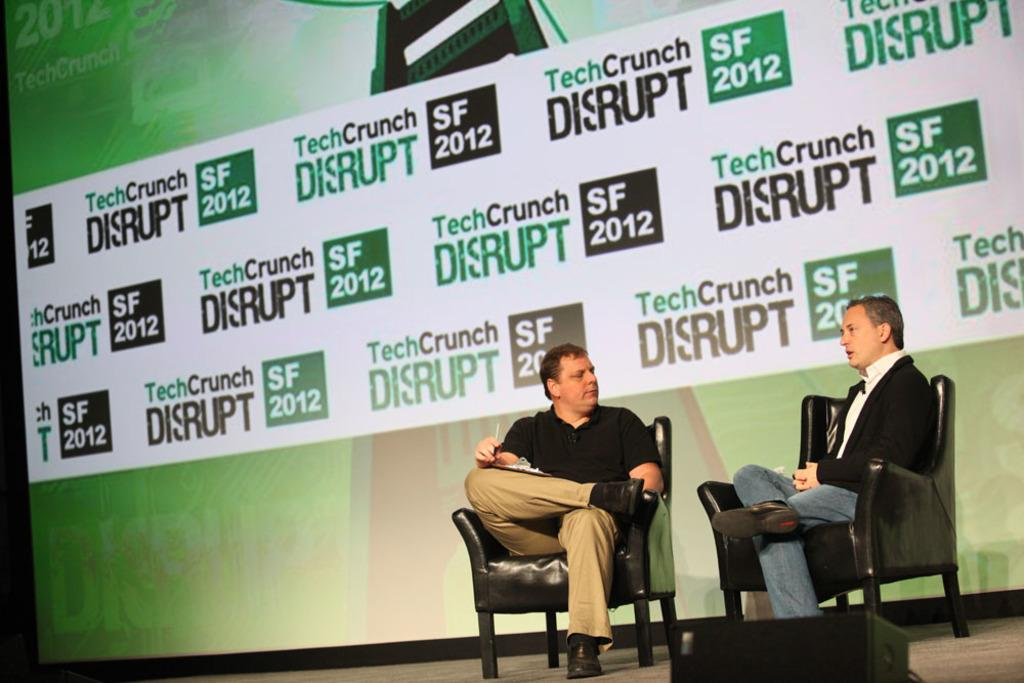How many people are sitting in the chairs in the image? There are two persons sitting on chairs in the image. What is the person on the left wearing? The person on the left is wearing a black and brown dress. What is the person in the black and brown dress holding? The person in the black and brown dress is holding a writing pad. What can be seen in the background of the image? There is a banner in the background. What is located in the front of the image? There is a speaker in the front. Can you tell me how many boys are sitting on the chairs in the image? There is no boy present in the image; both persons are adults. What type of yarn is being used to create the banner in the image? There is no yarn present in the image; the banner is made of a different material. 